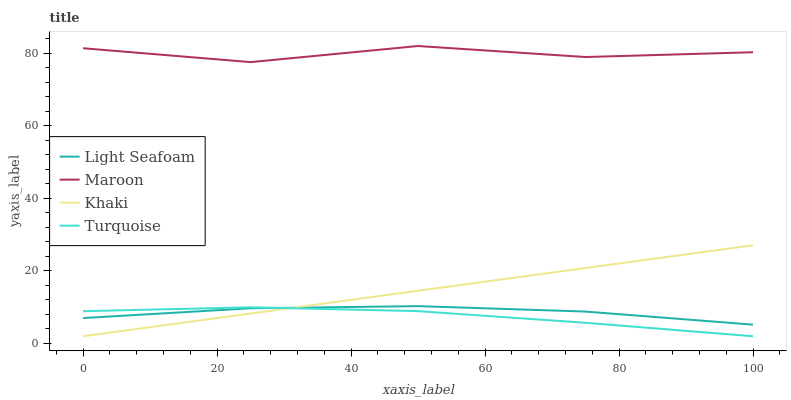Does Light Seafoam have the minimum area under the curve?
Answer yes or no. No. Does Light Seafoam have the maximum area under the curve?
Answer yes or no. No. Is Light Seafoam the smoothest?
Answer yes or no. No. Is Light Seafoam the roughest?
Answer yes or no. No. Does Light Seafoam have the lowest value?
Answer yes or no. No. Does Light Seafoam have the highest value?
Answer yes or no. No. Is Light Seafoam less than Maroon?
Answer yes or no. Yes. Is Maroon greater than Light Seafoam?
Answer yes or no. Yes. Does Light Seafoam intersect Maroon?
Answer yes or no. No. 